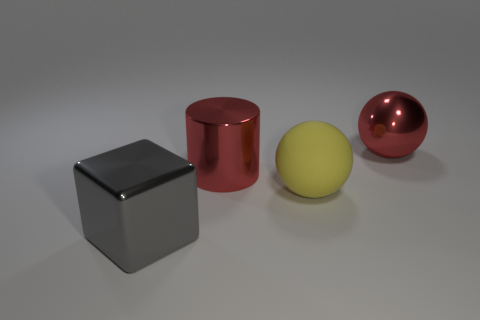Is there any other thing that has the same material as the yellow ball?
Make the answer very short. No. Is the number of big objects that are in front of the large cylinder greater than the number of big yellow balls?
Provide a succinct answer. Yes. The thing that is both to the right of the large red cylinder and left of the big red shiny ball is made of what material?
Give a very brief answer. Rubber. There is a metallic thing that is in front of the large rubber object; is its color the same as the sphere that is in front of the large metallic sphere?
Give a very brief answer. No. How many other objects are the same size as the red sphere?
Provide a succinct answer. 3. Are there any big red metallic cylinders that are behind the large red metallic object that is left of the ball to the right of the yellow matte object?
Make the answer very short. No. Do the large red thing left of the red shiny ball and the yellow object have the same material?
Your answer should be compact. No. There is another thing that is the same shape as the yellow thing; what is its color?
Your response must be concise. Red. Is there any other thing that has the same shape as the big gray metallic thing?
Offer a terse response. No. Is the number of big red things right of the big matte object the same as the number of yellow matte objects?
Your answer should be compact. Yes. 